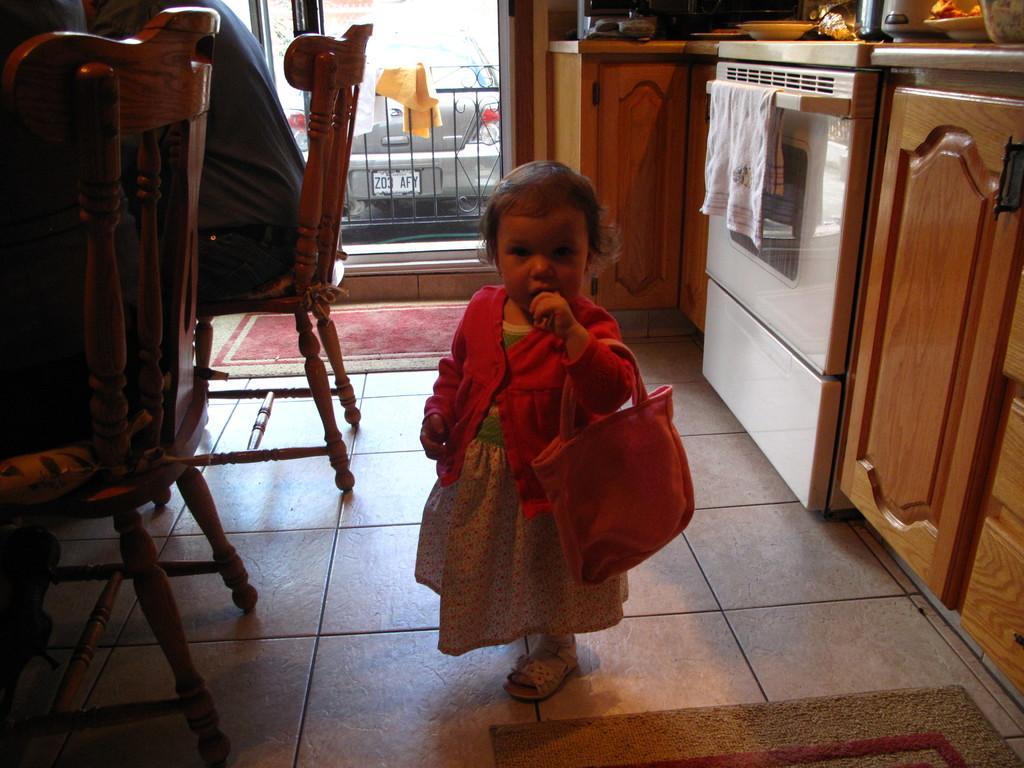Describe this image in one or two sentences. In this image i can see a girl child standing wearing a pink dress, holding a bag. To the left of the image i can see some chairs people siting on them and to the right of the image i can see a Owen and a counter top. In the background i can see a railing, clothes and a vehicle. 